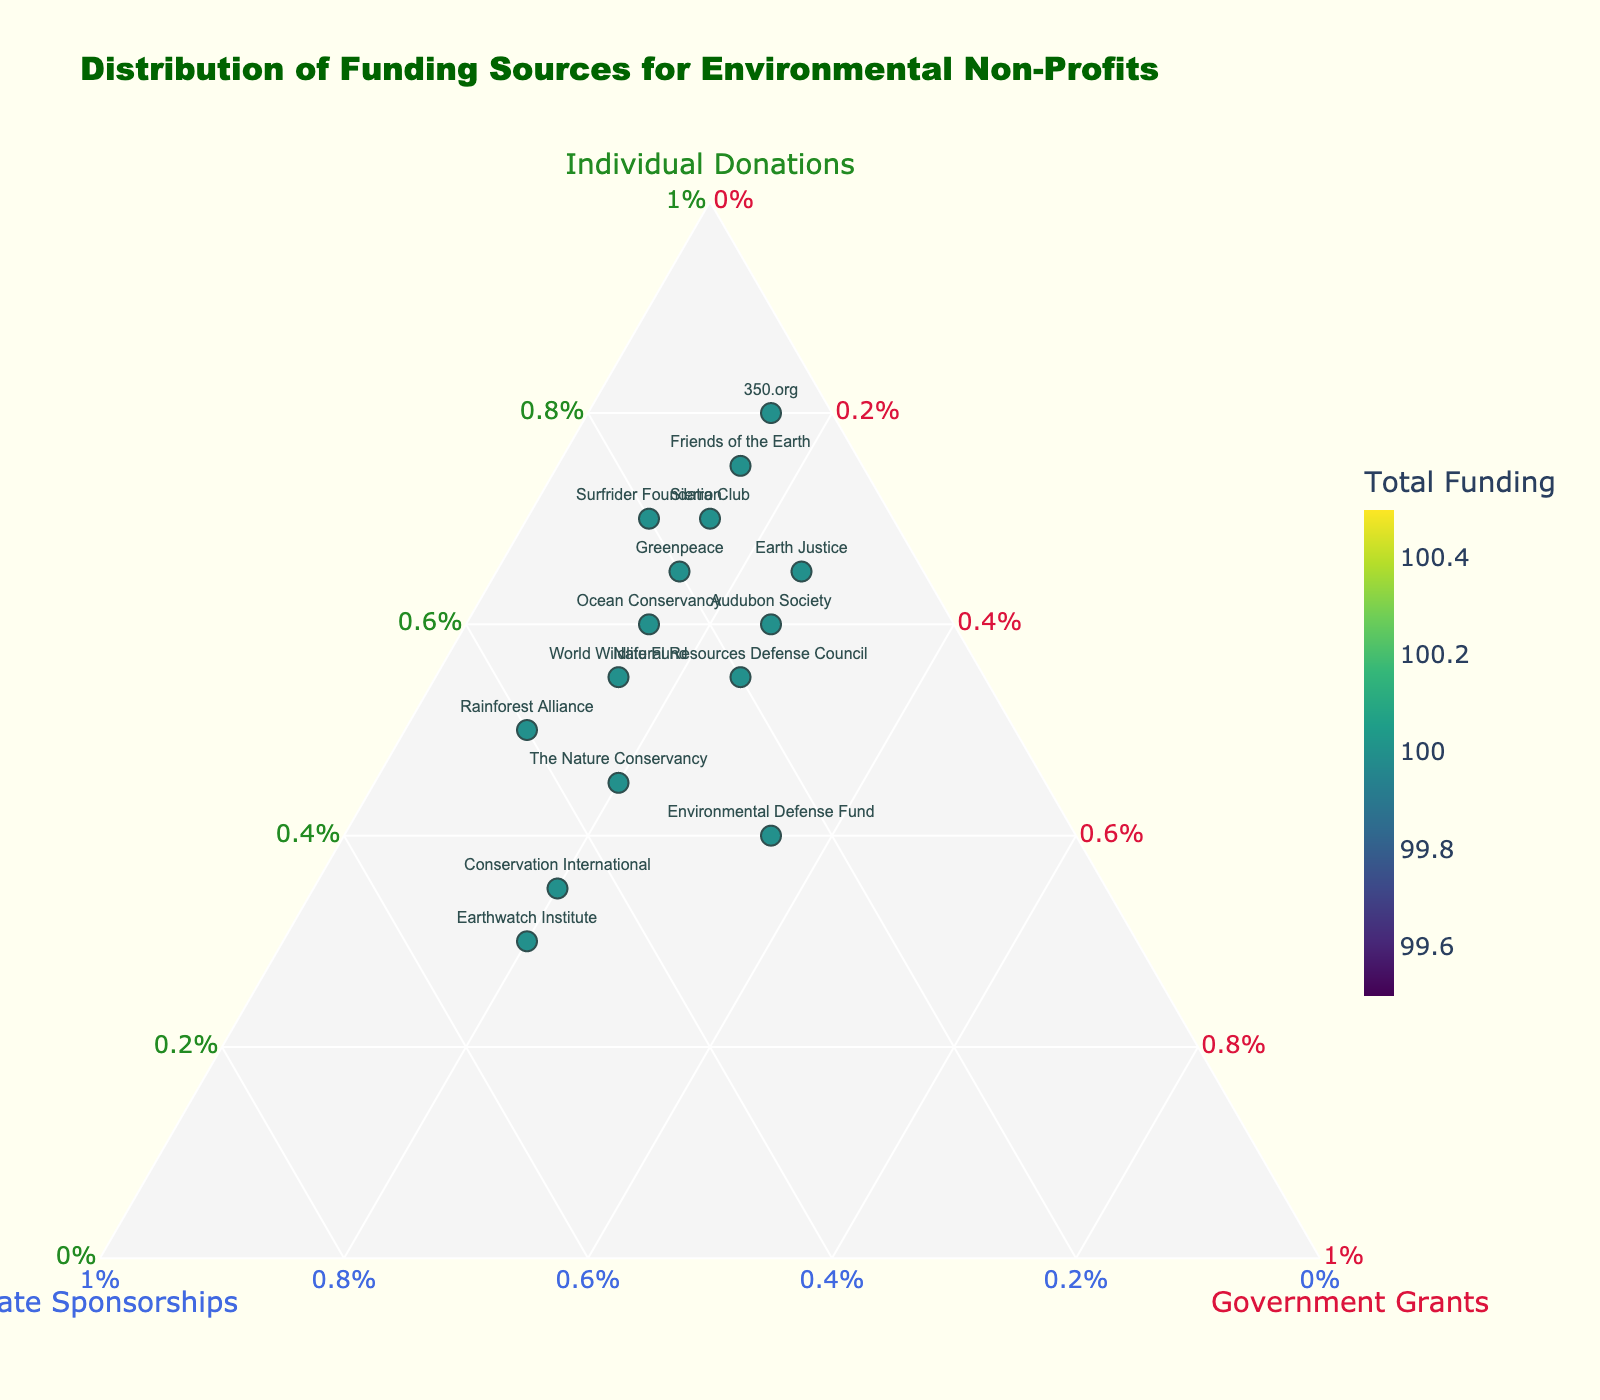How many organizations have more than 50% funding from individual donations? Look for the organizations whose position on the plot is closer to the "Individual Donations" vertex, specifically those with a value greater than 50% on the "Individual Donations" axis.
Answer: 9 Which organization has the highest percentage of corporate sponsorships? Look for the organization positioned closest to the "Corporate Sponsorships" vertex; this organization will have the maximum percentage of corporate sponsorships.
Answer: Earthwatch Institute What is the range of government grants percentages across all organizations? Identify the minimum and maximum values from the "Government Grants" axis for all the plotted organizations and calculate the difference between these values.
Answer: 10% to 35% Which organization relies most heavily on a single type of funding source? Look for the organization nearest to one of the three vertices (Individual Donations, Corporate Sponsorships, or Government Grants), indicating a high dependency on one source.
Answer: 350.org How does the funding distribution of Audubon Society compare to Sierra Club? Compare the positions of Audubon Society and Sierra Club on the ternary plot, specifically examining their relative percentages along all three axes.
Answer: Audubon Society has lower individual donations but higher government grants compared to Sierra Club Which organization has the most balanced funding distribution? Identify the organization closest to the center of the ternary plot, indicating relatively equal funding from all three sources.
Answer: Environmental Defense Fund What can be inferred about the relationship between government grants and corporate sponsorships for organizations? Analyze the density and clustering of organizations between the "Corporate Sponsorships" and "Government Grants" vertices to determine any patterns or trends.
Answer: Organizations with high government grants tend to have lower corporate sponsorships Is there any organization that has a similar funding distribution to The Nature Conservancy? Look for organizations positioned close to The Nature Conservancy on the ternary plot, indicating similar funding percentages from all three sources.
Answer: Rainforest Alliance has a similar distribution Which funding source is generally the least relied upon by the organizations? Determine which side of the ternary plot shows the fewest organizations closest to its corresponding vertex, indicating it is the least relied upon.
Answer: Government grants What is the average percentage of individual donations for all organizations? Calculate the average of the "Individual Donations" percentages from all plotted organizations by summing the values and dividing by the number of organizations.
Answer: 57% 